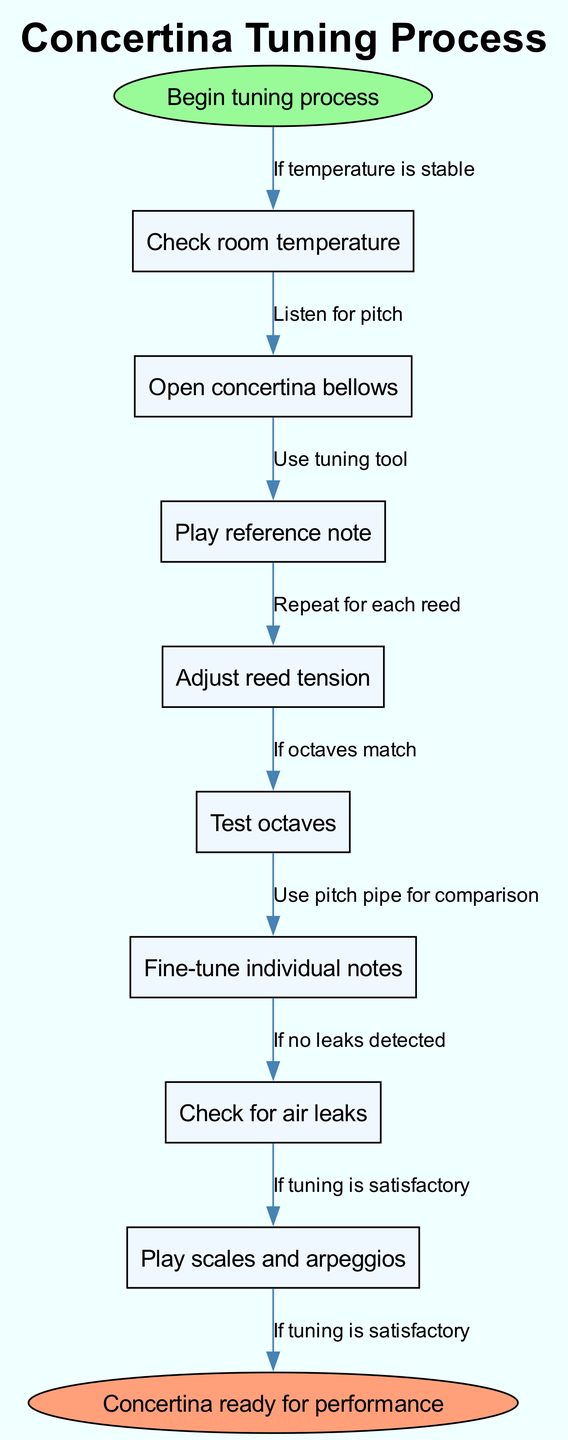What's the first step in the tuning process? The diagram starts with the node labeled "Begin tuning process," which is the first action taken in the flowchart.
Answer: Check room temperature How many main steps are there in the tuning process? The diagram has a total of 8 main nodes, representing the key steps involved in tuning the concertina.
Answer: 8 What action follows "Open concertina bellows"? The arrow leads from "Open concertina bellows" to "Play reference note," indicating the next action in the sequence.
Answer: Play reference note What should you do if octaves do not match? After reaching "Test octaves," the flow indicates that if the octaves do not match, further tuning will be needed, but the specific node related to this 'if' condition is not directly depicted. However, the process infers tuning action would follow.
Answer: Use tuning tool What is the final step before the concertina is ready? The last node before reaching the final state is labeled as "Play scales and arpeggios," which leads to the conclusion of the process indicated by "Concertina ready for performance."
Answer: Play scales and arpeggios Which step comes after checking for air leaks? Following "Check for air leaks," the flow chart indicates that if no leaks are detected, the next step is to ensure the tuning is satisfactory.
Answer: If tuning is satisfactory If reed tension needs adjustment, what would you likely be doing? In the sequence, "Adjust reed tension" is listed, following "Play reference note," which signifies that after hearing the reference note, you would adjust the reed tension accordingly.
Answer: Adjust reed tension What condition must be met before playing scales and arpeggios? Before moving to "Play scales and arpeggios," the condition is that the tuning must be satisfactory, as indicated by the flow edge coming from the previous node.
Answer: If tuning is satisfactory 